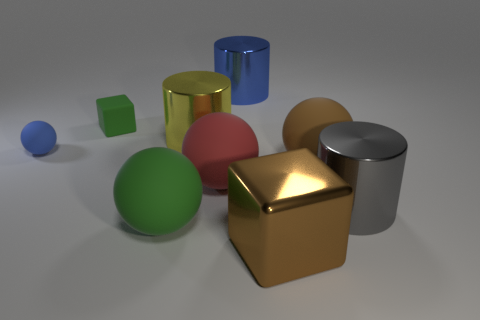Which objects in the image are geometric shapes and what are their colors? In the image, every object is a representation of a geometric shape. We have a blue sphere, a green cube, a small blue sphere, a red sphere, a shiny gold cube, a metallic silver cylinder, and a matte brown large sphere. Each object's color is as mentioned, which adds to the diversity of shapes and colors visible. 